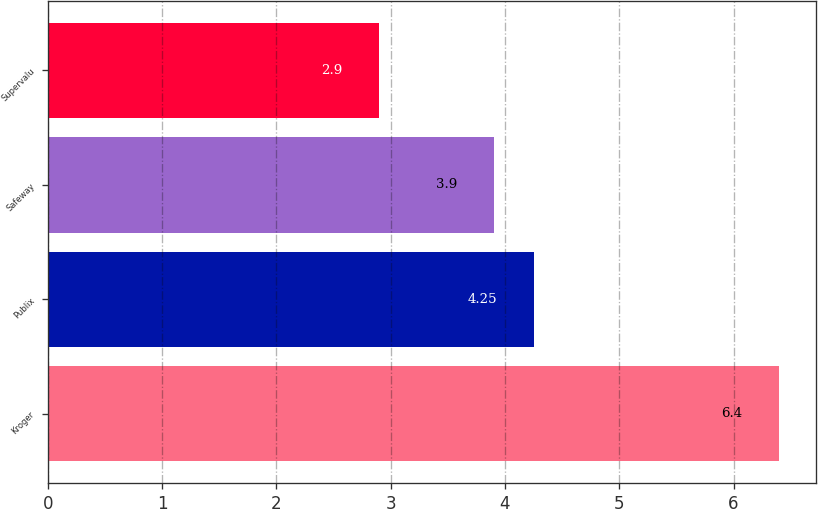Convert chart. <chart><loc_0><loc_0><loc_500><loc_500><bar_chart><fcel>Kroger<fcel>Publix<fcel>Safeway<fcel>Supervalu<nl><fcel>6.4<fcel>4.25<fcel>3.9<fcel>2.9<nl></chart> 